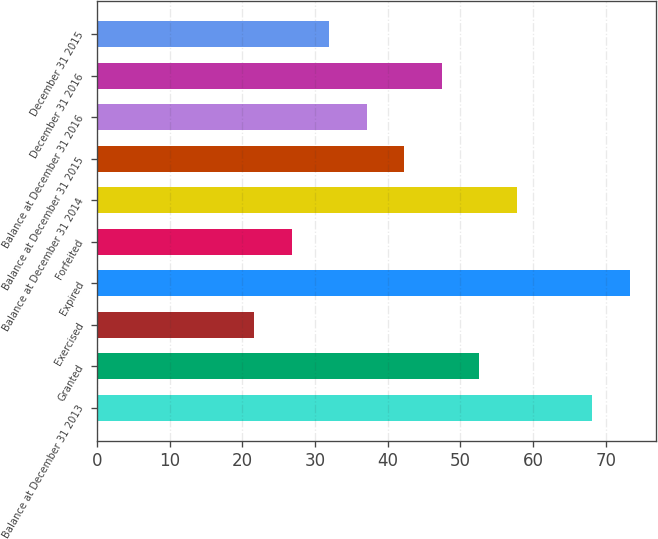Convert chart. <chart><loc_0><loc_0><loc_500><loc_500><bar_chart><fcel>Balance at December 31 2013<fcel>Granted<fcel>Exercised<fcel>Expired<fcel>Forfeited<fcel>Balance at December 31 2014<fcel>Balance at December 31 2015<fcel>Balance at December 31 2016<fcel>December 31 2016<fcel>December 31 2015<nl><fcel>68.13<fcel>52.62<fcel>21.6<fcel>73.3<fcel>26.77<fcel>57.79<fcel>42.28<fcel>37.11<fcel>47.45<fcel>31.94<nl></chart> 